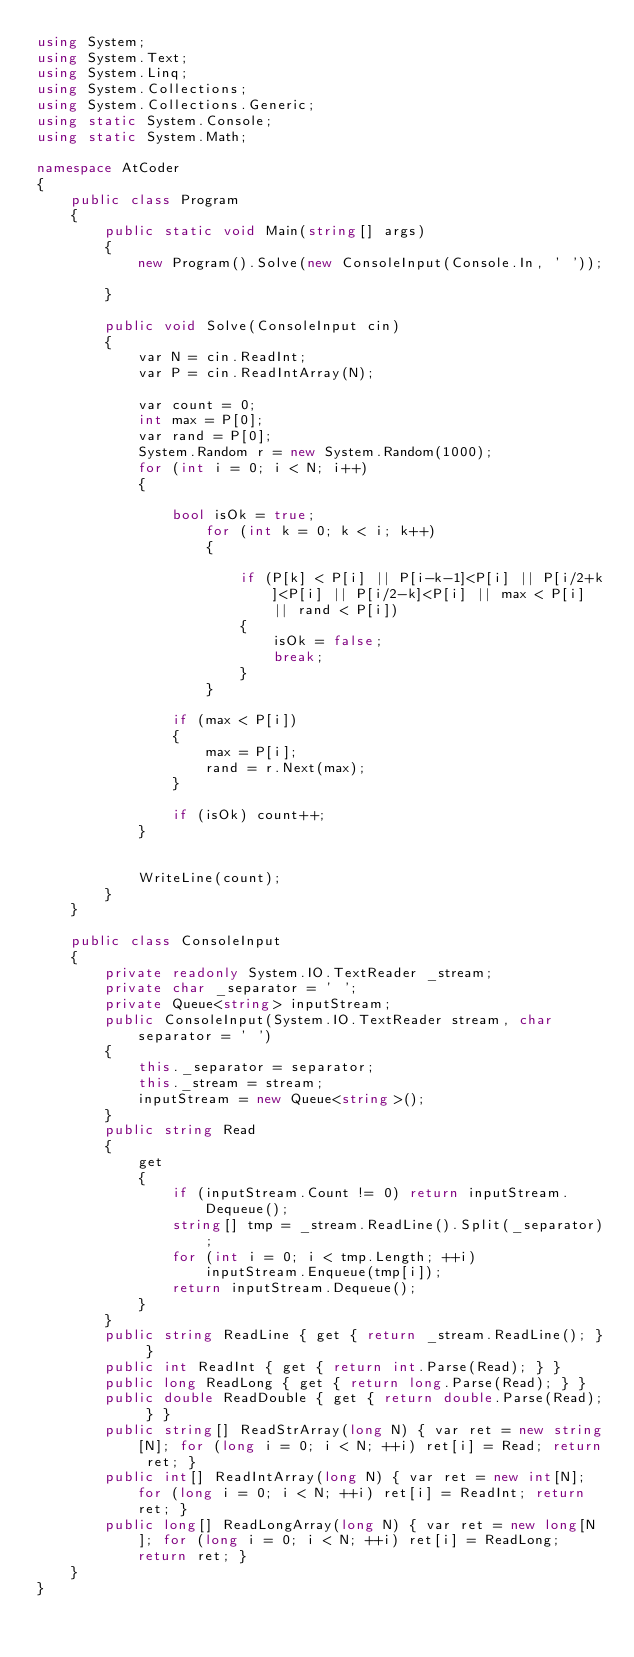Convert code to text. <code><loc_0><loc_0><loc_500><loc_500><_C#_>using System;
using System.Text;
using System.Linq;
using System.Collections;
using System.Collections.Generic;
using static System.Console;
using static System.Math;

namespace AtCoder
{
    public class Program
    {
        public static void Main(string[] args)
        {
            new Program().Solve(new ConsoleInput(Console.In, ' '));

        }

        public void Solve(ConsoleInput cin)
        {
            var N = cin.ReadInt;
            var P = cin.ReadIntArray(N);

            var count = 0;
            int max = P[0];
            var rand = P[0];
            System.Random r = new System.Random(1000);
            for (int i = 0; i < N; i++)
            {
                
                bool isOk = true;
                    for (int k = 0; k < i; k++)
                    {

                        if (P[k] < P[i] || P[i-k-1]<P[i] || P[i/2+k]<P[i] || P[i/2-k]<P[i] || max < P[i] || rand < P[i])
                        {
                            isOk = false;
                            break;
                        }
                    }

                if (max < P[i])
                {
                    max = P[i];
                    rand = r.Next(max);
                }

                if (isOk) count++;
            }


            WriteLine(count);
        }
    }

    public class ConsoleInput
    {
        private readonly System.IO.TextReader _stream;
        private char _separator = ' ';
        private Queue<string> inputStream;
        public ConsoleInput(System.IO.TextReader stream, char separator = ' ')
        {
            this._separator = separator;
            this._stream = stream;
            inputStream = new Queue<string>();
        }
        public string Read
        {
            get
            {
                if (inputStream.Count != 0) return inputStream.Dequeue();
                string[] tmp = _stream.ReadLine().Split(_separator);
                for (int i = 0; i < tmp.Length; ++i)
                    inputStream.Enqueue(tmp[i]);
                return inputStream.Dequeue();
            }
        }
        public string ReadLine { get { return _stream.ReadLine(); } }
        public int ReadInt { get { return int.Parse(Read); } }
        public long ReadLong { get { return long.Parse(Read); } }
        public double ReadDouble { get { return double.Parse(Read); } }
        public string[] ReadStrArray(long N) { var ret = new string[N]; for (long i = 0; i < N; ++i) ret[i] = Read; return ret; }
        public int[] ReadIntArray(long N) { var ret = new int[N]; for (long i = 0; i < N; ++i) ret[i] = ReadInt; return ret; }
        public long[] ReadLongArray(long N) { var ret = new long[N]; for (long i = 0; i < N; ++i) ret[i] = ReadLong; return ret; }
    }
}</code> 